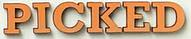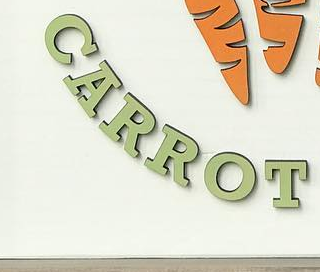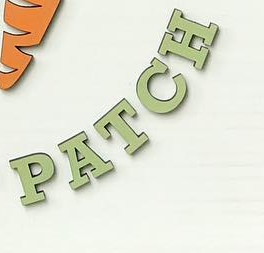What text appears in these images from left to right, separated by a semicolon? PICKED; CARROT; PATCH 